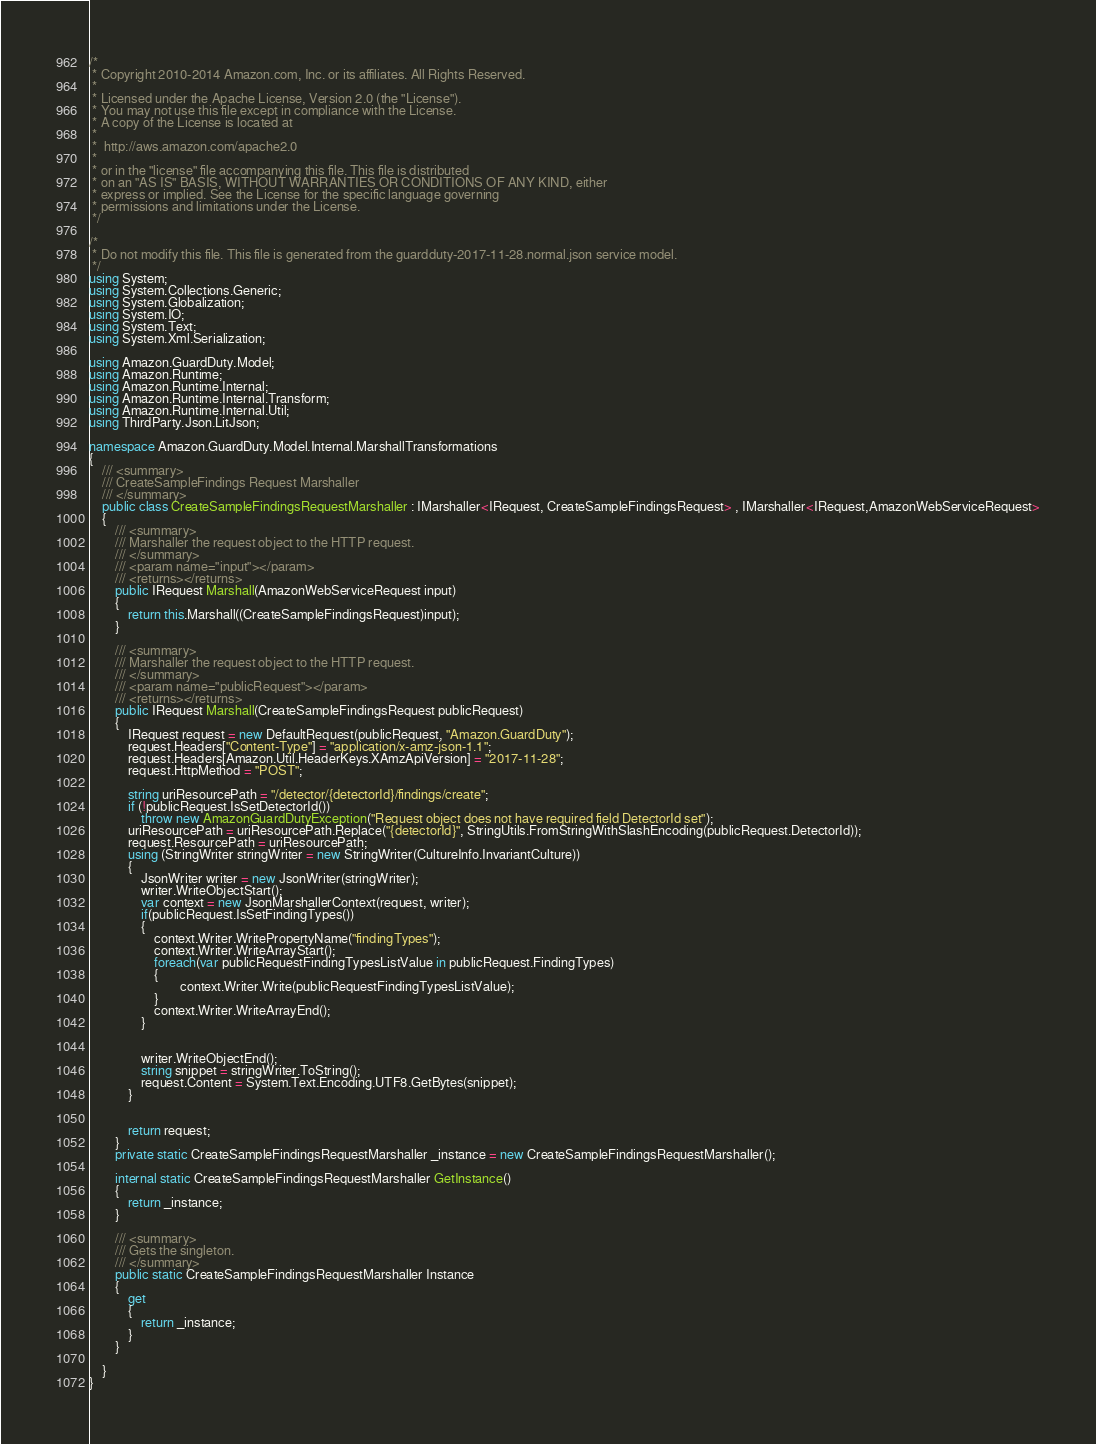Convert code to text. <code><loc_0><loc_0><loc_500><loc_500><_C#_>/*
 * Copyright 2010-2014 Amazon.com, Inc. or its affiliates. All Rights Reserved.
 * 
 * Licensed under the Apache License, Version 2.0 (the "License").
 * You may not use this file except in compliance with the License.
 * A copy of the License is located at
 * 
 *  http://aws.amazon.com/apache2.0
 * 
 * or in the "license" file accompanying this file. This file is distributed
 * on an "AS IS" BASIS, WITHOUT WARRANTIES OR CONDITIONS OF ANY KIND, either
 * express or implied. See the License for the specific language governing
 * permissions and limitations under the License.
 */

/*
 * Do not modify this file. This file is generated from the guardduty-2017-11-28.normal.json service model.
 */
using System;
using System.Collections.Generic;
using System.Globalization;
using System.IO;
using System.Text;
using System.Xml.Serialization;

using Amazon.GuardDuty.Model;
using Amazon.Runtime;
using Amazon.Runtime.Internal;
using Amazon.Runtime.Internal.Transform;
using Amazon.Runtime.Internal.Util;
using ThirdParty.Json.LitJson;

namespace Amazon.GuardDuty.Model.Internal.MarshallTransformations
{
    /// <summary>
    /// CreateSampleFindings Request Marshaller
    /// </summary>       
    public class CreateSampleFindingsRequestMarshaller : IMarshaller<IRequest, CreateSampleFindingsRequest> , IMarshaller<IRequest,AmazonWebServiceRequest>
    {
        /// <summary>
        /// Marshaller the request object to the HTTP request.
        /// </summary>  
        /// <param name="input"></param>
        /// <returns></returns>
        public IRequest Marshall(AmazonWebServiceRequest input)
        {
            return this.Marshall((CreateSampleFindingsRequest)input);
        }

        /// <summary>
        /// Marshaller the request object to the HTTP request.
        /// </summary>  
        /// <param name="publicRequest"></param>
        /// <returns></returns>
        public IRequest Marshall(CreateSampleFindingsRequest publicRequest)
        {
            IRequest request = new DefaultRequest(publicRequest, "Amazon.GuardDuty");
            request.Headers["Content-Type"] = "application/x-amz-json-1.1";
            request.Headers[Amazon.Util.HeaderKeys.XAmzApiVersion] = "2017-11-28";            
            request.HttpMethod = "POST";

            string uriResourcePath = "/detector/{detectorId}/findings/create";
            if (!publicRequest.IsSetDetectorId())
                throw new AmazonGuardDutyException("Request object does not have required field DetectorId set");
            uriResourcePath = uriResourcePath.Replace("{detectorId}", StringUtils.FromStringWithSlashEncoding(publicRequest.DetectorId));
            request.ResourcePath = uriResourcePath;
            using (StringWriter stringWriter = new StringWriter(CultureInfo.InvariantCulture))
            {
                JsonWriter writer = new JsonWriter(stringWriter);
                writer.WriteObjectStart();
                var context = new JsonMarshallerContext(request, writer);
                if(publicRequest.IsSetFindingTypes())
                {
                    context.Writer.WritePropertyName("findingTypes");
                    context.Writer.WriteArrayStart();
                    foreach(var publicRequestFindingTypesListValue in publicRequest.FindingTypes)
                    {
                            context.Writer.Write(publicRequestFindingTypesListValue);
                    }
                    context.Writer.WriteArrayEnd();
                }

        
                writer.WriteObjectEnd();
                string snippet = stringWriter.ToString();
                request.Content = System.Text.Encoding.UTF8.GetBytes(snippet);
            }


            return request;
        }
        private static CreateSampleFindingsRequestMarshaller _instance = new CreateSampleFindingsRequestMarshaller();        

        internal static CreateSampleFindingsRequestMarshaller GetInstance()
        {
            return _instance;
        }

        /// <summary>
        /// Gets the singleton.
        /// </summary>  
        public static CreateSampleFindingsRequestMarshaller Instance
        {
            get
            {
                return _instance;
            }
        }

    }
}</code> 